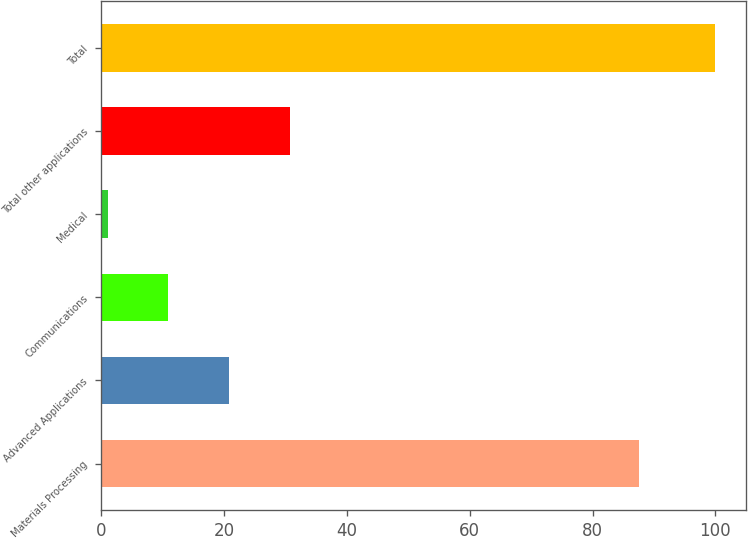Convert chart to OTSL. <chart><loc_0><loc_0><loc_500><loc_500><bar_chart><fcel>Materials Processing<fcel>Advanced Applications<fcel>Communications<fcel>Medical<fcel>Total other applications<fcel>Total<nl><fcel>87.5<fcel>20.8<fcel>10.9<fcel>1<fcel>30.7<fcel>100<nl></chart> 